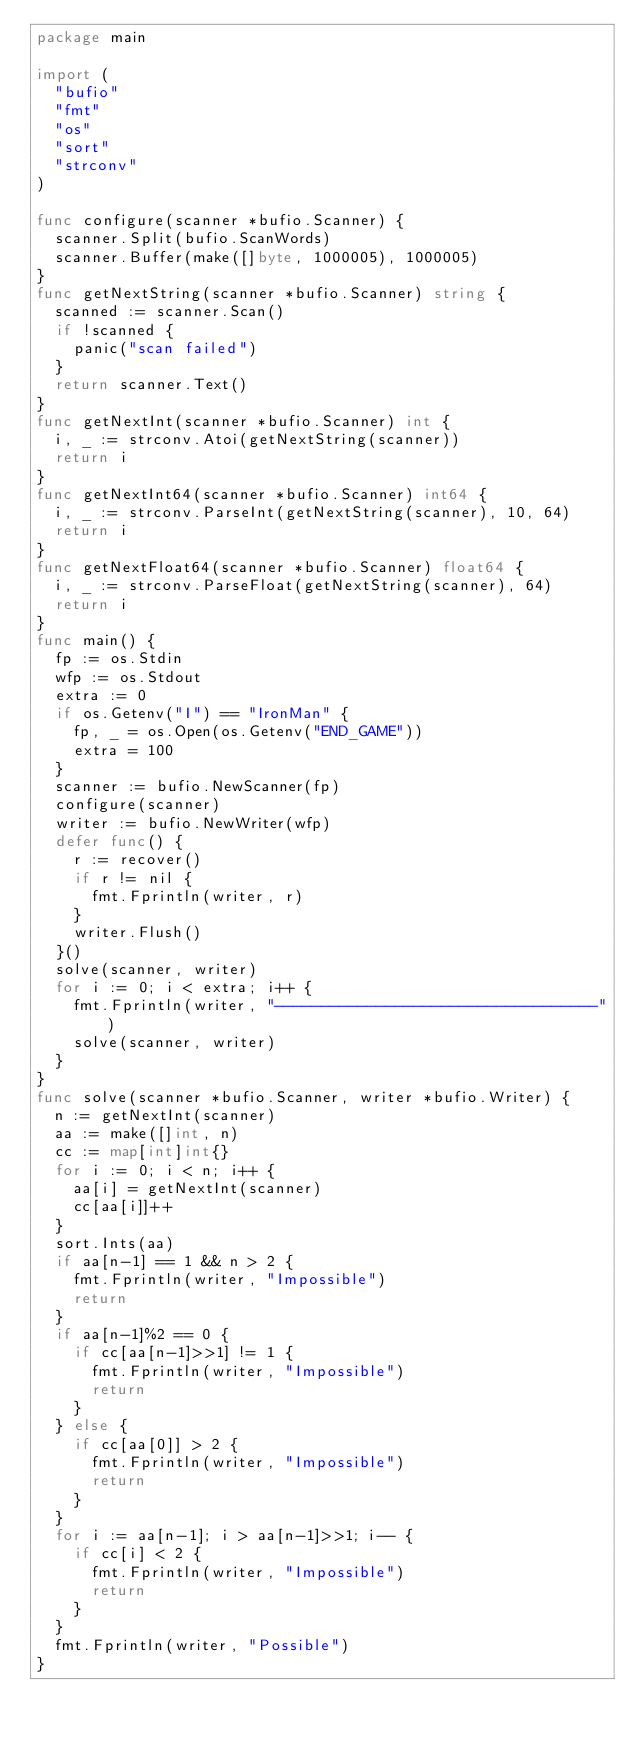Convert code to text. <code><loc_0><loc_0><loc_500><loc_500><_Go_>package main

import (
	"bufio"
	"fmt"
	"os"
	"sort"
	"strconv"
)

func configure(scanner *bufio.Scanner) {
	scanner.Split(bufio.ScanWords)
	scanner.Buffer(make([]byte, 1000005), 1000005)
}
func getNextString(scanner *bufio.Scanner) string {
	scanned := scanner.Scan()
	if !scanned {
		panic("scan failed")
	}
	return scanner.Text()
}
func getNextInt(scanner *bufio.Scanner) int {
	i, _ := strconv.Atoi(getNextString(scanner))
	return i
}
func getNextInt64(scanner *bufio.Scanner) int64 {
	i, _ := strconv.ParseInt(getNextString(scanner), 10, 64)
	return i
}
func getNextFloat64(scanner *bufio.Scanner) float64 {
	i, _ := strconv.ParseFloat(getNextString(scanner), 64)
	return i
}
func main() {
	fp := os.Stdin
	wfp := os.Stdout
	extra := 0
	if os.Getenv("I") == "IronMan" {
		fp, _ = os.Open(os.Getenv("END_GAME"))
		extra = 100
	}
	scanner := bufio.NewScanner(fp)
	configure(scanner)
	writer := bufio.NewWriter(wfp)
	defer func() {
		r := recover()
		if r != nil {
			fmt.Fprintln(writer, r)
		}
		writer.Flush()
	}()
	solve(scanner, writer)
	for i := 0; i < extra; i++ {
		fmt.Fprintln(writer, "-----------------------------------")
		solve(scanner, writer)
	}
}
func solve(scanner *bufio.Scanner, writer *bufio.Writer) {
	n := getNextInt(scanner)
	aa := make([]int, n)
	cc := map[int]int{}
	for i := 0; i < n; i++ {
		aa[i] = getNextInt(scanner)
		cc[aa[i]]++
	}
	sort.Ints(aa)
	if aa[n-1] == 1 && n > 2 {
		fmt.Fprintln(writer, "Impossible")
		return
	}
	if aa[n-1]%2 == 0 {
		if cc[aa[n-1]>>1] != 1 {
			fmt.Fprintln(writer, "Impossible")
			return
		}
	} else {
		if cc[aa[0]] > 2 {
			fmt.Fprintln(writer, "Impossible")
			return
		}
	}
	for i := aa[n-1]; i > aa[n-1]>>1; i-- {
		if cc[i] < 2 {
			fmt.Fprintln(writer, "Impossible")
			return
		}
	}
	fmt.Fprintln(writer, "Possible")
}
</code> 